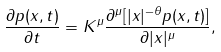<formula> <loc_0><loc_0><loc_500><loc_500>\frac { \partial p ( x , t ) } { \partial t } = K ^ { \mu } \frac { \partial ^ { \mu } [ | x | ^ { - \theta } p ( x , t ) ] } { \partial | x | ^ { \mu } } ,</formula> 